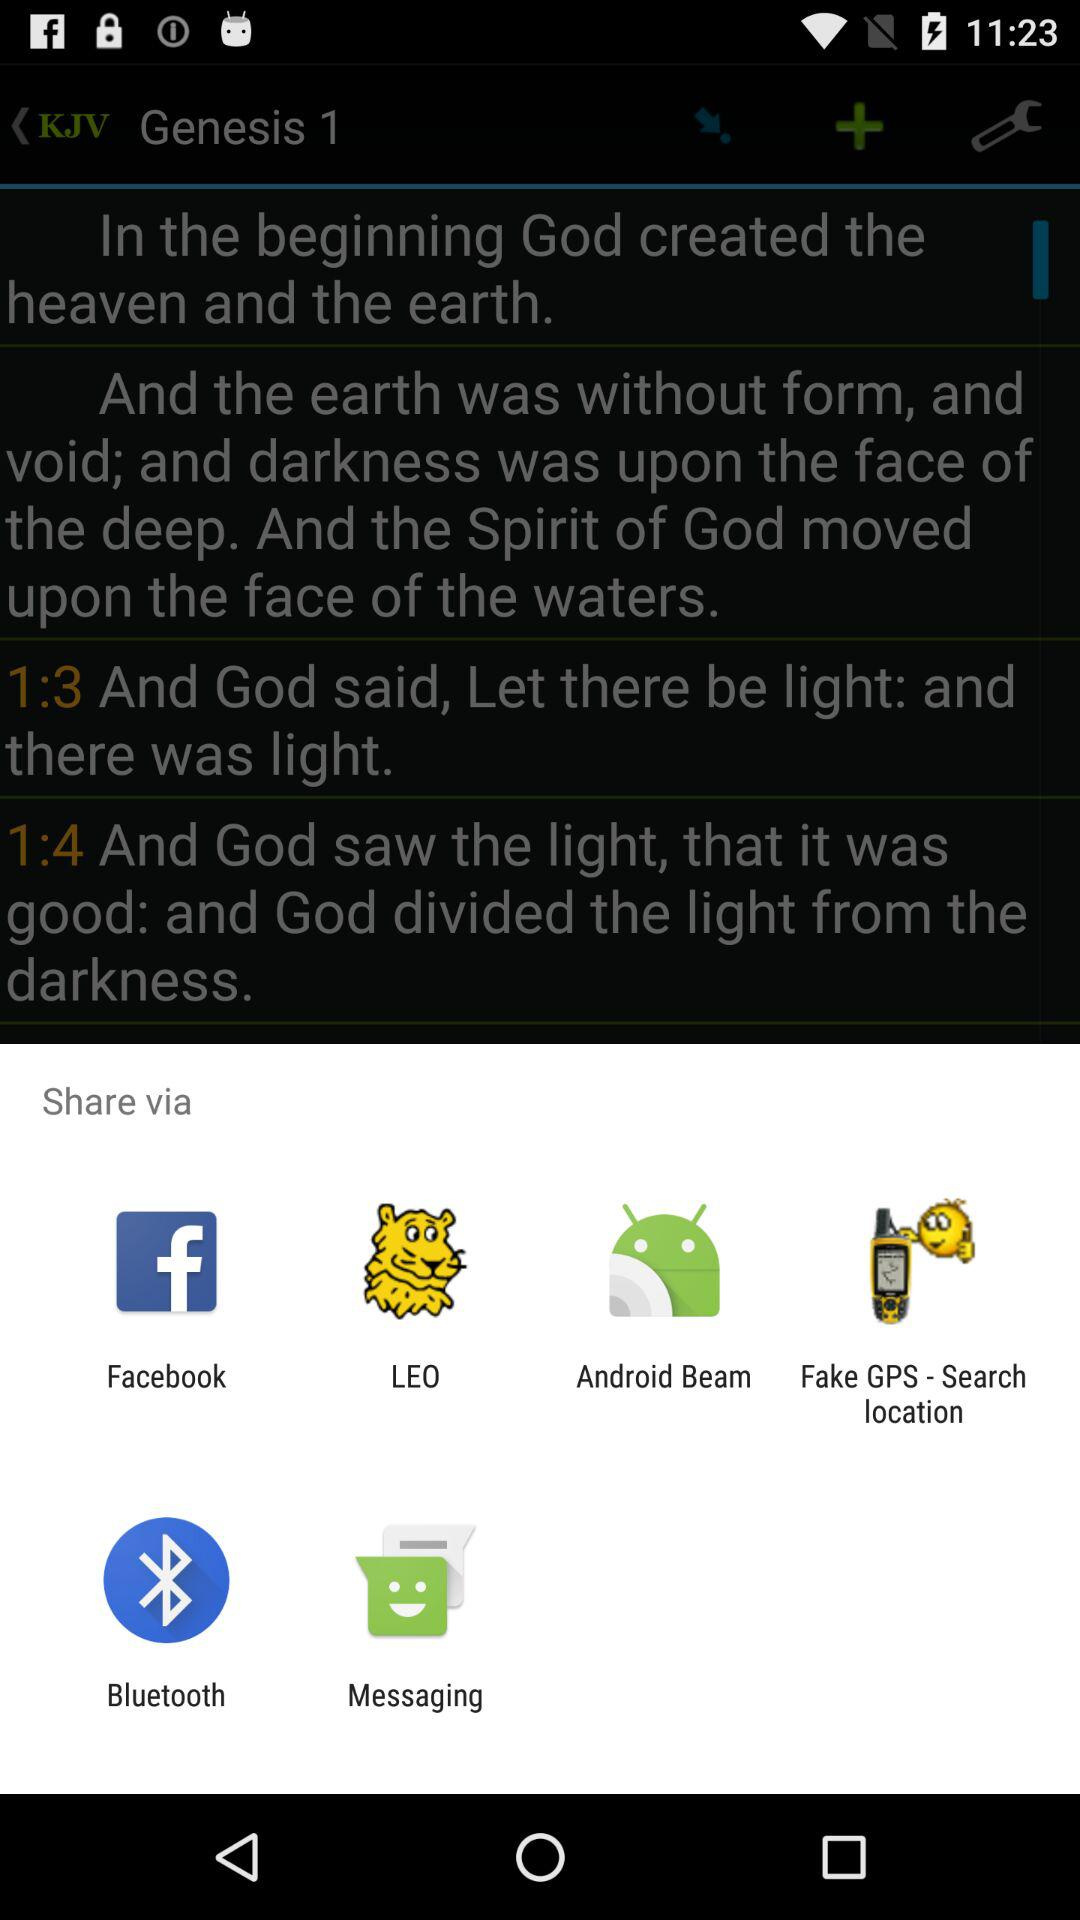What are the sharing options? The sharing options are "Facebook", "LEO", "Android Beam", "Fake GPS - Search location", "Bluetooth" and "Messaging". 